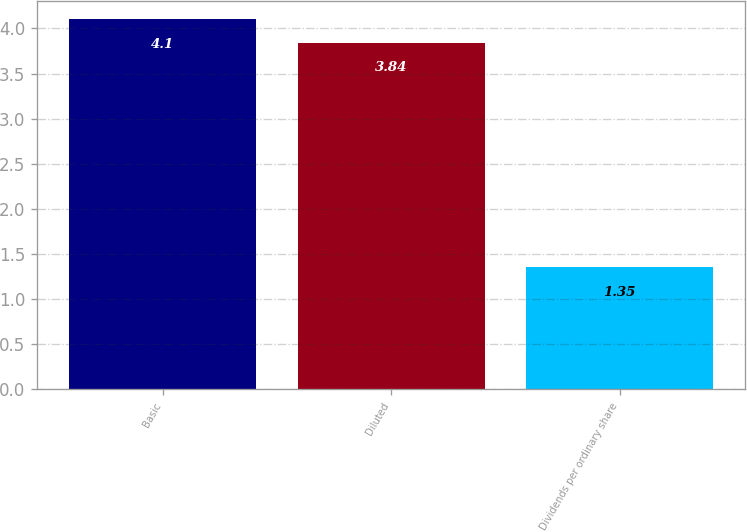Convert chart to OTSL. <chart><loc_0><loc_0><loc_500><loc_500><bar_chart><fcel>Basic<fcel>Diluted<fcel>Dividends per ordinary share<nl><fcel>4.1<fcel>3.84<fcel>1.35<nl></chart> 